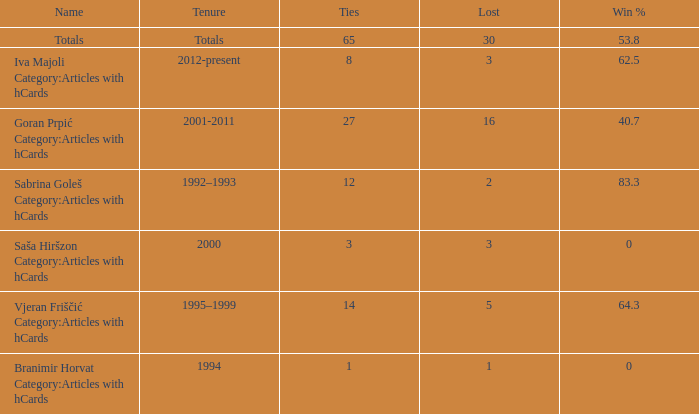Tell me the total number of ties for name of totals and lost more than 30 0.0. 